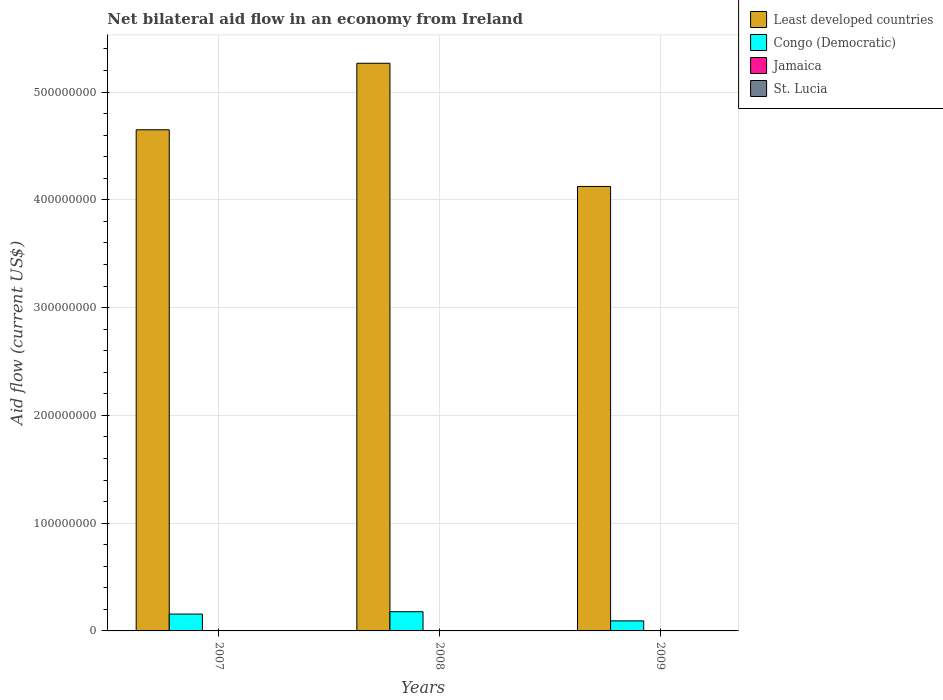How many groups of bars are there?
Offer a terse response. 3. Are the number of bars per tick equal to the number of legend labels?
Your response must be concise. Yes. Are the number of bars on each tick of the X-axis equal?
Give a very brief answer. Yes. How many bars are there on the 3rd tick from the right?
Keep it short and to the point. 4. What is the net bilateral aid flow in St. Lucia in 2009?
Make the answer very short. 6.00e+04. Across all years, what is the maximum net bilateral aid flow in Congo (Democratic)?
Provide a succinct answer. 1.78e+07. In which year was the net bilateral aid flow in St. Lucia maximum?
Make the answer very short. 2007. In which year was the net bilateral aid flow in Jamaica minimum?
Offer a terse response. 2007. What is the total net bilateral aid flow in St. Lucia in the graph?
Offer a very short reply. 1.60e+05. What is the difference between the net bilateral aid flow in Jamaica in 2007 and the net bilateral aid flow in Least developed countries in 2008?
Ensure brevity in your answer.  -5.27e+08. What is the average net bilateral aid flow in Congo (Democratic) per year?
Ensure brevity in your answer.  1.43e+07. In the year 2008, what is the difference between the net bilateral aid flow in Congo (Democratic) and net bilateral aid flow in Least developed countries?
Your answer should be compact. -5.09e+08. In how many years, is the net bilateral aid flow in St. Lucia greater than 300000000 US$?
Offer a very short reply. 0. What is the ratio of the net bilateral aid flow in Jamaica in 2007 to that in 2009?
Give a very brief answer. 0.11. Is the net bilateral aid flow in Congo (Democratic) in 2007 less than that in 2008?
Offer a very short reply. Yes. Is the difference between the net bilateral aid flow in Congo (Democratic) in 2008 and 2009 greater than the difference between the net bilateral aid flow in Least developed countries in 2008 and 2009?
Provide a short and direct response. No. What is the difference between the highest and the second highest net bilateral aid flow in St. Lucia?
Offer a terse response. 3.00e+04. What is the difference between the highest and the lowest net bilateral aid flow in Least developed countries?
Give a very brief answer. 1.14e+08. In how many years, is the net bilateral aid flow in Least developed countries greater than the average net bilateral aid flow in Least developed countries taken over all years?
Ensure brevity in your answer.  1. What does the 2nd bar from the left in 2008 represents?
Offer a very short reply. Congo (Democratic). What does the 1st bar from the right in 2007 represents?
Keep it short and to the point. St. Lucia. How many bars are there?
Ensure brevity in your answer.  12. Are all the bars in the graph horizontal?
Your answer should be very brief. No. Are the values on the major ticks of Y-axis written in scientific E-notation?
Your answer should be very brief. No. Does the graph contain any zero values?
Provide a short and direct response. No. How are the legend labels stacked?
Your answer should be very brief. Vertical. What is the title of the graph?
Your answer should be compact. Net bilateral aid flow in an economy from Ireland. Does "Germany" appear as one of the legend labels in the graph?
Your answer should be very brief. No. What is the label or title of the X-axis?
Give a very brief answer. Years. What is the label or title of the Y-axis?
Provide a succinct answer. Aid flow (current US$). What is the Aid flow (current US$) in Least developed countries in 2007?
Make the answer very short. 4.65e+08. What is the Aid flow (current US$) in Congo (Democratic) in 2007?
Provide a short and direct response. 1.56e+07. What is the Aid flow (current US$) in Least developed countries in 2008?
Keep it short and to the point. 5.27e+08. What is the Aid flow (current US$) of Congo (Democratic) in 2008?
Keep it short and to the point. 1.78e+07. What is the Aid flow (current US$) of Jamaica in 2008?
Provide a succinct answer. 2.20e+05. What is the Aid flow (current US$) of Least developed countries in 2009?
Offer a terse response. 4.12e+08. What is the Aid flow (current US$) of Congo (Democratic) in 2009?
Offer a terse response. 9.32e+06. Across all years, what is the maximum Aid flow (current US$) of Least developed countries?
Keep it short and to the point. 5.27e+08. Across all years, what is the maximum Aid flow (current US$) in Congo (Democratic)?
Your answer should be very brief. 1.78e+07. Across all years, what is the minimum Aid flow (current US$) in Least developed countries?
Make the answer very short. 4.12e+08. Across all years, what is the minimum Aid flow (current US$) of Congo (Democratic)?
Keep it short and to the point. 9.32e+06. Across all years, what is the minimum Aid flow (current US$) of St. Lucia?
Keep it short and to the point. 10000. What is the total Aid flow (current US$) of Least developed countries in the graph?
Your response must be concise. 1.40e+09. What is the total Aid flow (current US$) in Congo (Democratic) in the graph?
Keep it short and to the point. 4.28e+07. What is the total Aid flow (current US$) of Jamaica in the graph?
Keep it short and to the point. 6.10e+05. What is the total Aid flow (current US$) of St. Lucia in the graph?
Give a very brief answer. 1.60e+05. What is the difference between the Aid flow (current US$) of Least developed countries in 2007 and that in 2008?
Offer a very short reply. -6.17e+07. What is the difference between the Aid flow (current US$) in Congo (Democratic) in 2007 and that in 2008?
Your answer should be compact. -2.18e+06. What is the difference between the Aid flow (current US$) in St. Lucia in 2007 and that in 2008?
Provide a short and direct response. 8.00e+04. What is the difference between the Aid flow (current US$) of Least developed countries in 2007 and that in 2009?
Ensure brevity in your answer.  5.26e+07. What is the difference between the Aid flow (current US$) of Congo (Democratic) in 2007 and that in 2009?
Provide a succinct answer. 6.33e+06. What is the difference between the Aid flow (current US$) of Jamaica in 2007 and that in 2009?
Provide a succinct answer. -3.10e+05. What is the difference between the Aid flow (current US$) of Least developed countries in 2008 and that in 2009?
Keep it short and to the point. 1.14e+08. What is the difference between the Aid flow (current US$) in Congo (Democratic) in 2008 and that in 2009?
Your answer should be compact. 8.51e+06. What is the difference between the Aid flow (current US$) in Jamaica in 2008 and that in 2009?
Ensure brevity in your answer.  -1.30e+05. What is the difference between the Aid flow (current US$) in St. Lucia in 2008 and that in 2009?
Your response must be concise. -5.00e+04. What is the difference between the Aid flow (current US$) of Least developed countries in 2007 and the Aid flow (current US$) of Congo (Democratic) in 2008?
Offer a very short reply. 4.47e+08. What is the difference between the Aid flow (current US$) of Least developed countries in 2007 and the Aid flow (current US$) of Jamaica in 2008?
Offer a terse response. 4.65e+08. What is the difference between the Aid flow (current US$) of Least developed countries in 2007 and the Aid flow (current US$) of St. Lucia in 2008?
Provide a succinct answer. 4.65e+08. What is the difference between the Aid flow (current US$) of Congo (Democratic) in 2007 and the Aid flow (current US$) of Jamaica in 2008?
Ensure brevity in your answer.  1.54e+07. What is the difference between the Aid flow (current US$) of Congo (Democratic) in 2007 and the Aid flow (current US$) of St. Lucia in 2008?
Offer a terse response. 1.56e+07. What is the difference between the Aid flow (current US$) in Least developed countries in 2007 and the Aid flow (current US$) in Congo (Democratic) in 2009?
Ensure brevity in your answer.  4.56e+08. What is the difference between the Aid flow (current US$) in Least developed countries in 2007 and the Aid flow (current US$) in Jamaica in 2009?
Ensure brevity in your answer.  4.65e+08. What is the difference between the Aid flow (current US$) of Least developed countries in 2007 and the Aid flow (current US$) of St. Lucia in 2009?
Your response must be concise. 4.65e+08. What is the difference between the Aid flow (current US$) of Congo (Democratic) in 2007 and the Aid flow (current US$) of Jamaica in 2009?
Keep it short and to the point. 1.53e+07. What is the difference between the Aid flow (current US$) in Congo (Democratic) in 2007 and the Aid flow (current US$) in St. Lucia in 2009?
Provide a succinct answer. 1.56e+07. What is the difference between the Aid flow (current US$) of Jamaica in 2007 and the Aid flow (current US$) of St. Lucia in 2009?
Provide a succinct answer. -2.00e+04. What is the difference between the Aid flow (current US$) of Least developed countries in 2008 and the Aid flow (current US$) of Congo (Democratic) in 2009?
Your response must be concise. 5.17e+08. What is the difference between the Aid flow (current US$) of Least developed countries in 2008 and the Aid flow (current US$) of Jamaica in 2009?
Your answer should be compact. 5.26e+08. What is the difference between the Aid flow (current US$) in Least developed countries in 2008 and the Aid flow (current US$) in St. Lucia in 2009?
Provide a succinct answer. 5.27e+08. What is the difference between the Aid flow (current US$) of Congo (Democratic) in 2008 and the Aid flow (current US$) of Jamaica in 2009?
Make the answer very short. 1.75e+07. What is the difference between the Aid flow (current US$) of Congo (Democratic) in 2008 and the Aid flow (current US$) of St. Lucia in 2009?
Your answer should be very brief. 1.78e+07. What is the difference between the Aid flow (current US$) in Jamaica in 2008 and the Aid flow (current US$) in St. Lucia in 2009?
Keep it short and to the point. 1.60e+05. What is the average Aid flow (current US$) of Least developed countries per year?
Ensure brevity in your answer.  4.68e+08. What is the average Aid flow (current US$) in Congo (Democratic) per year?
Provide a short and direct response. 1.43e+07. What is the average Aid flow (current US$) in Jamaica per year?
Provide a succinct answer. 2.03e+05. What is the average Aid flow (current US$) in St. Lucia per year?
Provide a short and direct response. 5.33e+04. In the year 2007, what is the difference between the Aid flow (current US$) in Least developed countries and Aid flow (current US$) in Congo (Democratic)?
Keep it short and to the point. 4.49e+08. In the year 2007, what is the difference between the Aid flow (current US$) in Least developed countries and Aid flow (current US$) in Jamaica?
Offer a very short reply. 4.65e+08. In the year 2007, what is the difference between the Aid flow (current US$) in Least developed countries and Aid flow (current US$) in St. Lucia?
Your answer should be very brief. 4.65e+08. In the year 2007, what is the difference between the Aid flow (current US$) of Congo (Democratic) and Aid flow (current US$) of Jamaica?
Your answer should be very brief. 1.56e+07. In the year 2007, what is the difference between the Aid flow (current US$) of Congo (Democratic) and Aid flow (current US$) of St. Lucia?
Keep it short and to the point. 1.56e+07. In the year 2008, what is the difference between the Aid flow (current US$) of Least developed countries and Aid flow (current US$) of Congo (Democratic)?
Your response must be concise. 5.09e+08. In the year 2008, what is the difference between the Aid flow (current US$) in Least developed countries and Aid flow (current US$) in Jamaica?
Provide a short and direct response. 5.26e+08. In the year 2008, what is the difference between the Aid flow (current US$) in Least developed countries and Aid flow (current US$) in St. Lucia?
Provide a short and direct response. 5.27e+08. In the year 2008, what is the difference between the Aid flow (current US$) of Congo (Democratic) and Aid flow (current US$) of Jamaica?
Ensure brevity in your answer.  1.76e+07. In the year 2008, what is the difference between the Aid flow (current US$) of Congo (Democratic) and Aid flow (current US$) of St. Lucia?
Provide a short and direct response. 1.78e+07. In the year 2008, what is the difference between the Aid flow (current US$) in Jamaica and Aid flow (current US$) in St. Lucia?
Offer a terse response. 2.10e+05. In the year 2009, what is the difference between the Aid flow (current US$) in Least developed countries and Aid flow (current US$) in Congo (Democratic)?
Offer a terse response. 4.03e+08. In the year 2009, what is the difference between the Aid flow (current US$) of Least developed countries and Aid flow (current US$) of Jamaica?
Provide a succinct answer. 4.12e+08. In the year 2009, what is the difference between the Aid flow (current US$) of Least developed countries and Aid flow (current US$) of St. Lucia?
Make the answer very short. 4.12e+08. In the year 2009, what is the difference between the Aid flow (current US$) in Congo (Democratic) and Aid flow (current US$) in Jamaica?
Provide a succinct answer. 8.97e+06. In the year 2009, what is the difference between the Aid flow (current US$) in Congo (Democratic) and Aid flow (current US$) in St. Lucia?
Ensure brevity in your answer.  9.26e+06. In the year 2009, what is the difference between the Aid flow (current US$) in Jamaica and Aid flow (current US$) in St. Lucia?
Ensure brevity in your answer.  2.90e+05. What is the ratio of the Aid flow (current US$) of Least developed countries in 2007 to that in 2008?
Give a very brief answer. 0.88. What is the ratio of the Aid flow (current US$) in Congo (Democratic) in 2007 to that in 2008?
Ensure brevity in your answer.  0.88. What is the ratio of the Aid flow (current US$) of Jamaica in 2007 to that in 2008?
Give a very brief answer. 0.18. What is the ratio of the Aid flow (current US$) in St. Lucia in 2007 to that in 2008?
Your answer should be very brief. 9. What is the ratio of the Aid flow (current US$) of Least developed countries in 2007 to that in 2009?
Give a very brief answer. 1.13. What is the ratio of the Aid flow (current US$) of Congo (Democratic) in 2007 to that in 2009?
Your answer should be compact. 1.68. What is the ratio of the Aid flow (current US$) in Jamaica in 2007 to that in 2009?
Offer a very short reply. 0.11. What is the ratio of the Aid flow (current US$) of Least developed countries in 2008 to that in 2009?
Your answer should be compact. 1.28. What is the ratio of the Aid flow (current US$) in Congo (Democratic) in 2008 to that in 2009?
Make the answer very short. 1.91. What is the ratio of the Aid flow (current US$) in Jamaica in 2008 to that in 2009?
Make the answer very short. 0.63. What is the difference between the highest and the second highest Aid flow (current US$) in Least developed countries?
Your answer should be very brief. 6.17e+07. What is the difference between the highest and the second highest Aid flow (current US$) of Congo (Democratic)?
Your answer should be compact. 2.18e+06. What is the difference between the highest and the lowest Aid flow (current US$) of Least developed countries?
Provide a short and direct response. 1.14e+08. What is the difference between the highest and the lowest Aid flow (current US$) in Congo (Democratic)?
Provide a short and direct response. 8.51e+06. 